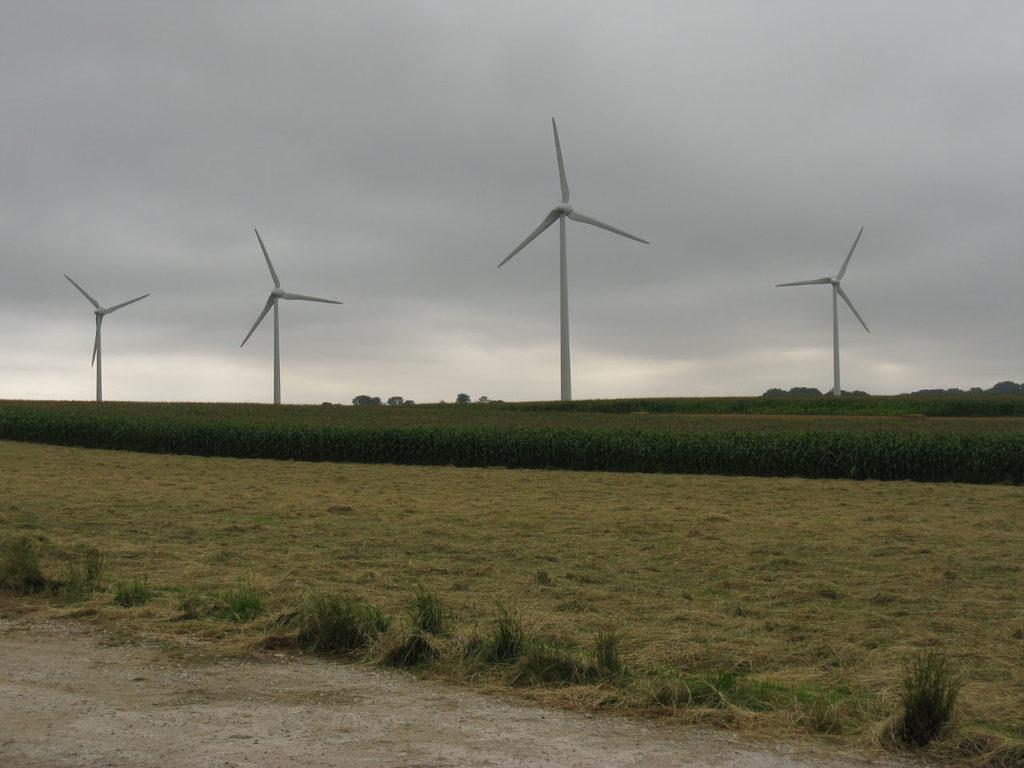What type of vegetation can be seen in the image? There is grass and plants in the image. What structure is located in the middle of the plants? There is a windmill in the middle of the plants. What is visible in the background of the image? There is a sky visible in the background of the image. What type of hair can be seen on the windmill in the image? There is no hair present on the windmill in the image. What type of trip is being taken by the plants in the image? The plants are stationary in the image and not taking any trip. 